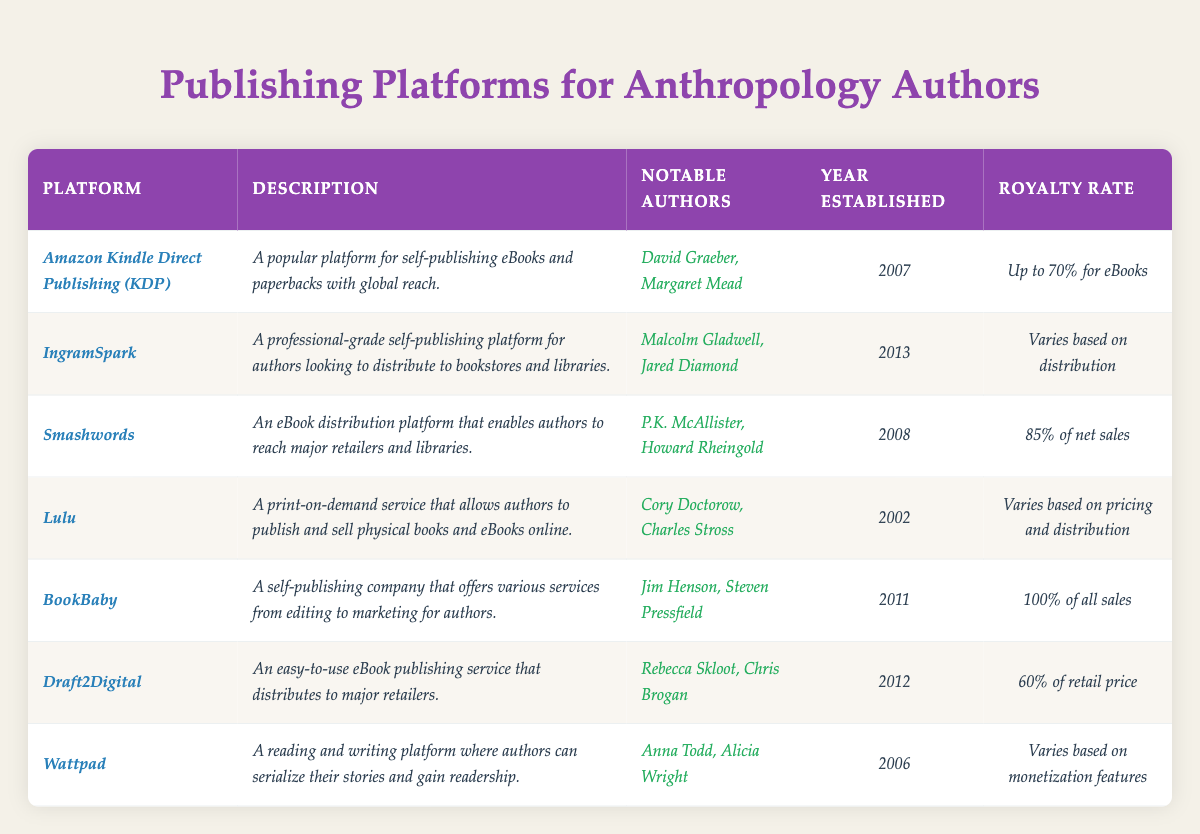What is the royalty rate for *BookBaby*? The table shows that the royalty rate for *BookBaby* is *100% of all sales*.
Answer: 100% of all sales Which platform was established first, *Lulu* or *Smashwords*? The table indicates that *Lulu* was established in *2002* and *Smashwords* in *2008*, making *Lulu* the earlier platform.
Answer: *Lulu* Name one notable author who uses *IngramSpark*. The table lists *Malcolm Gladwell* and *Jared Diamond* as notable authors who use *IngramSpark*.
Answer: *Malcolm Gladwell* What is the royal rate difference between *Draft2Digital* and *Smashwords*? *Draft2Digital* has a royalty rate of *60% of retail price*, while *Smashwords* has a rate of *85% of net sales*. The difference is 85% - 60% = 25%.
Answer: 25% Is *Wattpad* older than *Amazon Kindle Direct Publishing (KDP)*? The table shows *Wattpad* was established in *2006* and *KDP* in *2007*, so *Wattpad* is older.
Answer: Yes List all platforms that have a royalty rate of *up to 70% for eBooks*. The only platform listed with a royalty rate of *up to 70% for eBooks* is *Amazon Kindle Direct Publishing (KDP)*.
Answer: *Amazon Kindle Direct Publishing (KDP)* Which platform offers the lowest royalty rate based on the table? The table indicates that *Draft2Digital* has a royalty rate of *60% of retail price*, which is lower than the other rates listed.
Answer: 60% of retail price Which platform was established last and what is its notable author? The last established platform listed is *IngramSpark* in *2013*, and notable authors include *Malcolm Gladwell* and *Jared Diamond*.
Answer: *IngramSpark*, *Malcolm Gladwell* How many platforms allow authors to earn at least 70% or more of their sales? The two platforms that allow authors to earn at least 70% or more of their sales are *Smashwords* (85%) and *BookBaby* (100%), making a total of two platforms.
Answer: 2 Which platform focuses on print-on-demand services? The description for *Lulu* states it is a *print-on-demand service*, making it the platform focused on this service.
Answer: *Lulu* 